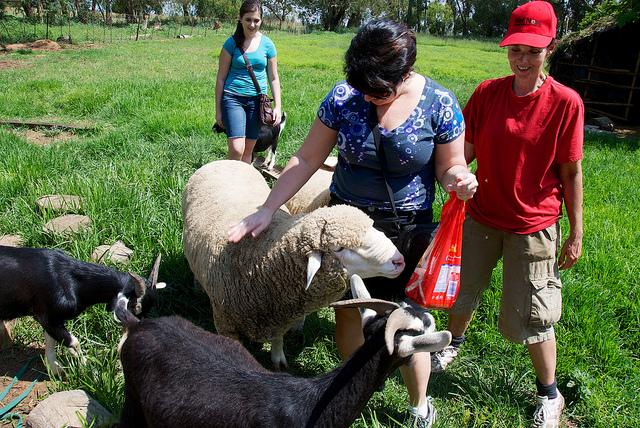Are any of the women wearing pants?
Quick response, please. No. What animals are this?
Short answer required. Sheep. What is the woman in red wearing on her head?
Write a very short answer. Hat. 